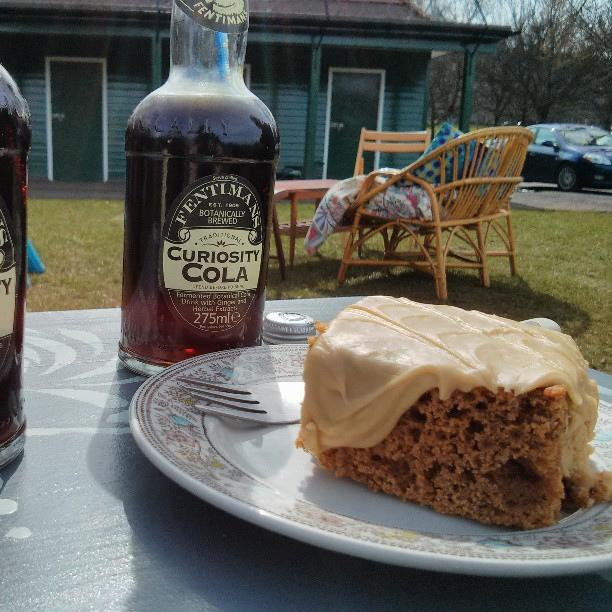What is the fork next to? Please explain your reasoning. cake. The fork is next to a piece of fluffy cake. 